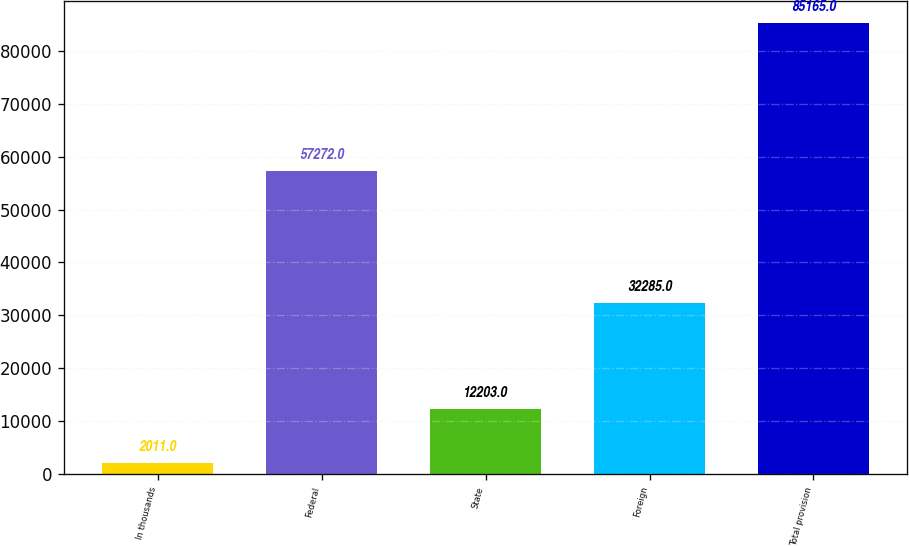Convert chart to OTSL. <chart><loc_0><loc_0><loc_500><loc_500><bar_chart><fcel>In thousands<fcel>Federal<fcel>State<fcel>Foreign<fcel>Total provision<nl><fcel>2011<fcel>57272<fcel>12203<fcel>32285<fcel>85165<nl></chart> 